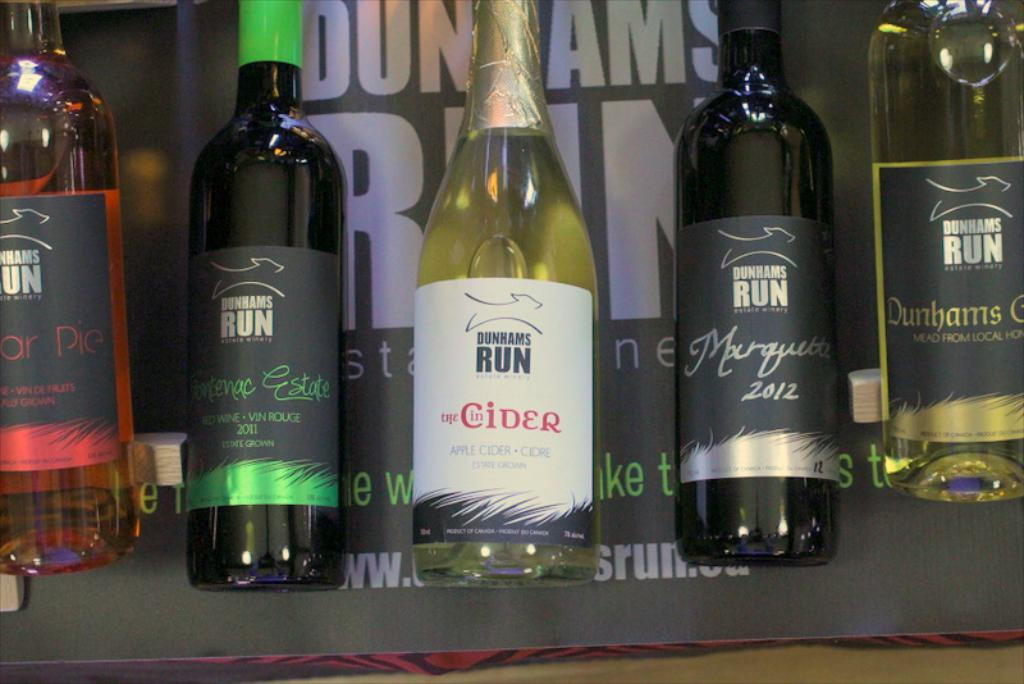Explore the design elements used on the labels of the products shown. Each label on Dunhams Run's products features a sleek, modern design with a consistent logo of a running horse, symbolizing dynamism and heritage. The color palette varies with each product, using darker hues for red wines and lighter tones for the cider and mead, creating a visual distinction that aligns with the flavor profiles and ingredients of each drink. 